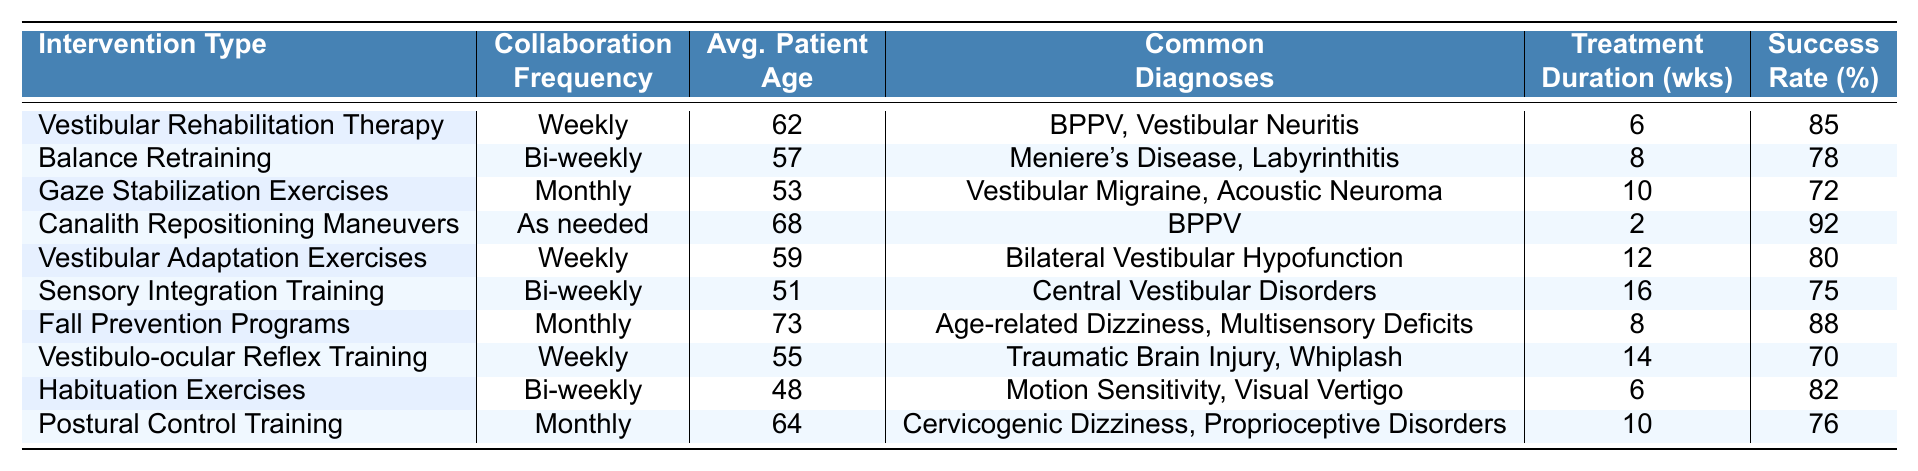What type of intervention has the highest success rate? By examining the "Success Rate (%)" column, we see that "Canalith Repositioning Maneuvers" has a success rate of 92%, which is higher than any other intervention listed.
Answer: Canalith Repositioning Maneuvers How often do audiologists and physical therapists collaborate for "Vestibular Adaptation Exercises"? According to the table, "Vestibular Adaptation Exercises" are conducted on a weekly basis.
Answer: Weekly What is the average patient age for interventions with monthly collaboration frequency? We look at the "Average Patient Age" for interventions that happen monthly: "Gaze Stabilization Exercises" (53), "Fall Prevention Programs" (73), and "Postural Control Training" (64). The average is (53 + 73 + 64) / 3 = 63.33.
Answer: 63.33 Is the success rate for "Sensory Integration Training" higher than that for "Balance Retraining"? "Sensory Integration Training" has a success rate of 75%, while "Balance Retraining" has a success rate of 78%. Since 75% is less than 78%, the statement is false.
Answer: False Which intervention has the oldest average patient age, and what is that age? Checking the "Average Patient Age" column, the intervention with the highest age is "Fall Prevention Programs" at 73 years old.
Answer: Fall Prevention Programs, 73 What is the treatment duration for "Vestibular Rehabilitation Therapy" compared to "Gaze Stabilization Exercises"? The treatment duration for "Vestibular Rehabilitation Therapy" is 6 weeks, while for "Gaze Stabilization Exercises," it is 10 weeks. The difference is 10 - 6 = 4 weeks longer for Gaze Stabilization Exercises.
Answer: 4 weeks What percentage of common diagnoses includes "BPPV"? "BPPV" appears in the common diagnoses for "Vestibular Rehabilitation Therapy" and "Canalith Repositioning Maneuvers". Since there are 10 entries in total, it represents 2 out of 10, which is 20%.
Answer: 20% Are the majority of interventions conducted on a weekly basis? Counting the "Collaboration Frequency" column, there are four interventions labeled as "Weekly" compared to just three "Bi-weekly" and three "Monthly" entries. Therefore, yes, the majority are on a weekly basis.
Answer: Yes What is the total success rate for interventions that occur bi-weekly? The success rates for bi-weekly interventions are 78% ("Balance Retraining"), 75% ("Sensory Integration Training"), and 82% ("Habituation Exercises"). Summing these gives 78 + 75 + 82 = 235, and the average is 235 / 3 = 78.33%.
Answer: 78.33% How does the average patient age for "Balance Retraining" compare to that of "Habituation Exercises"? The average patient age for "Balance Retraining" is 57, while for "Habituation Exercises," it is 48. Since 57 is greater than 48, "Balance Retraining" has an older average patient age.
Answer: Balance Retraining is older 